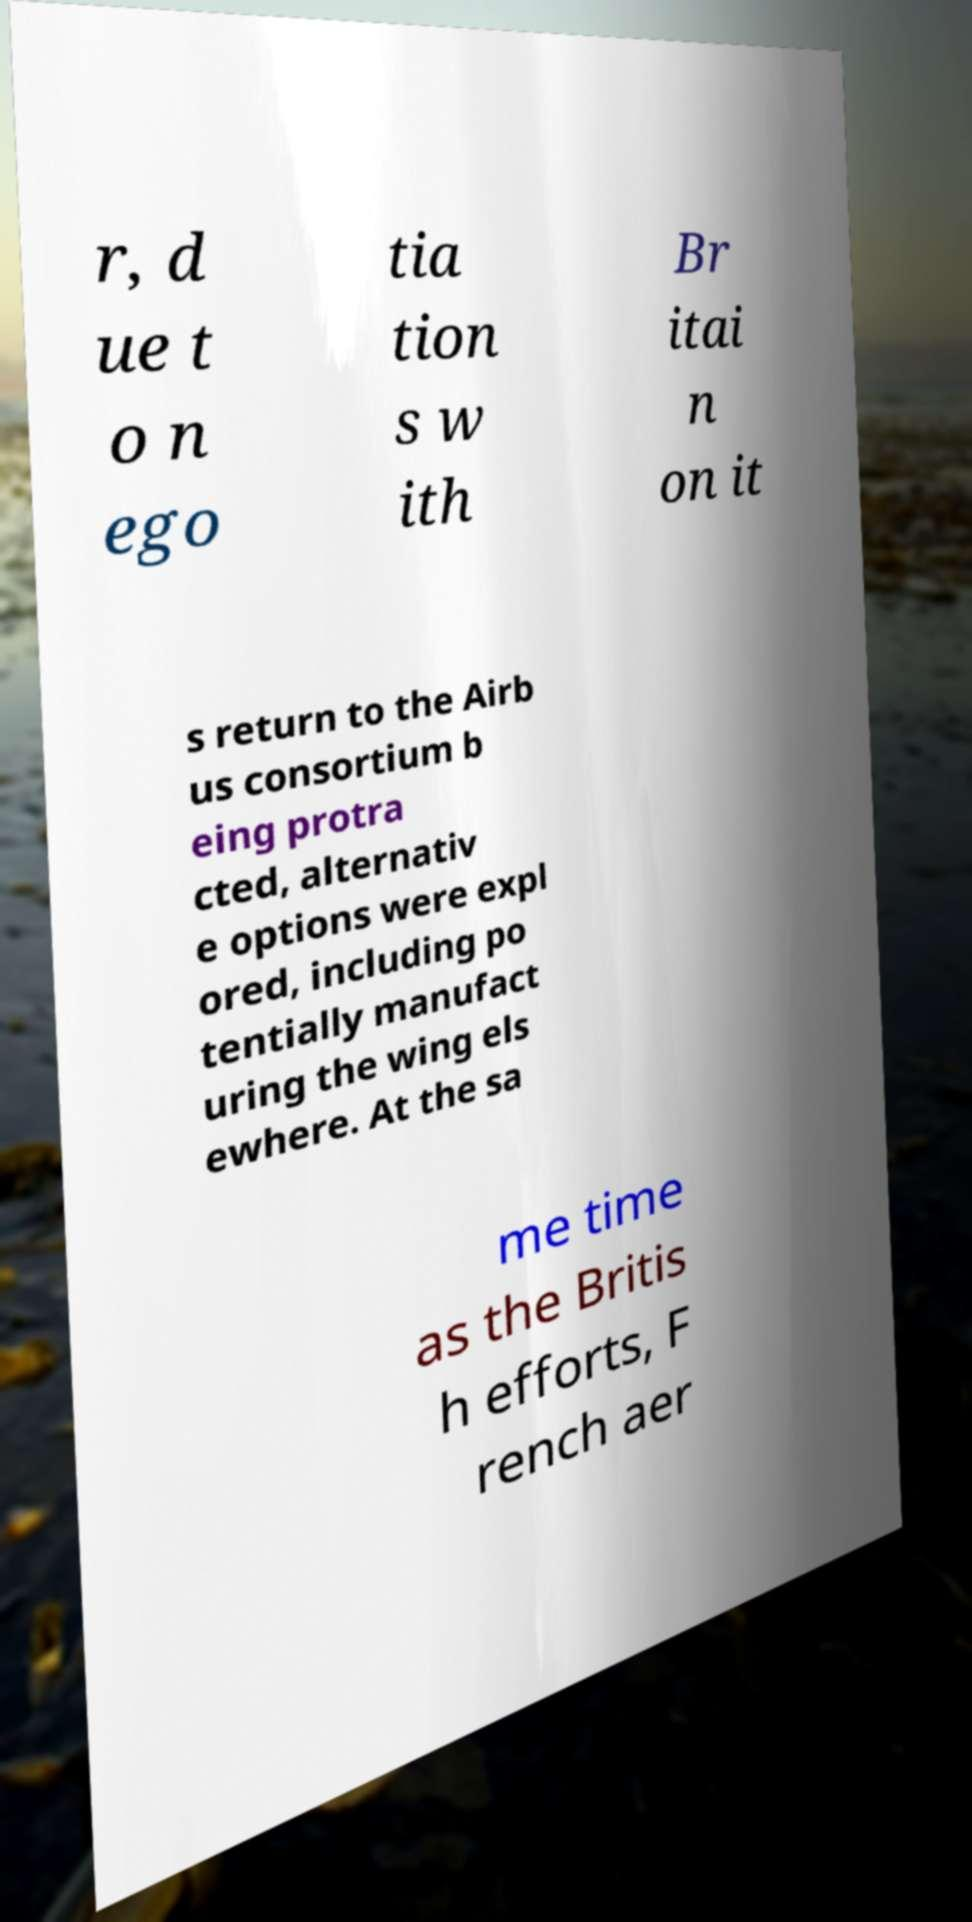Please read and relay the text visible in this image. What does it say? r, d ue t o n ego tia tion s w ith Br itai n on it s return to the Airb us consortium b eing protra cted, alternativ e options were expl ored, including po tentially manufact uring the wing els ewhere. At the sa me time as the Britis h efforts, F rench aer 